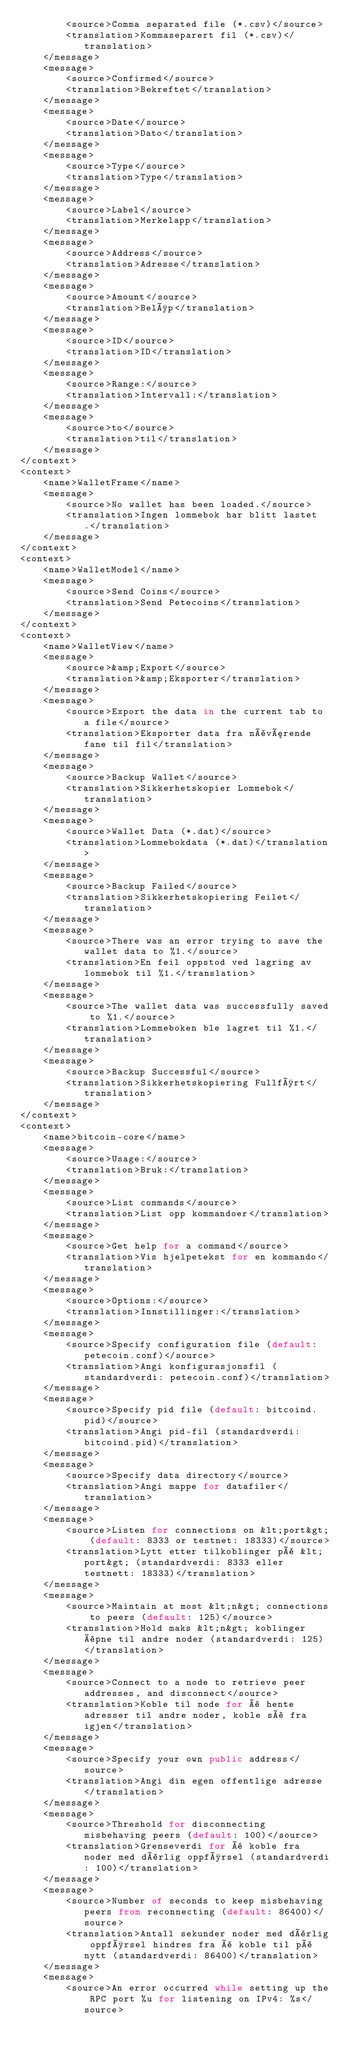<code> <loc_0><loc_0><loc_500><loc_500><_TypeScript_>        <source>Comma separated file (*.csv)</source>
        <translation>Kommaseparert fil (*.csv)</translation>
    </message>
    <message>
        <source>Confirmed</source>
        <translation>Bekreftet</translation>
    </message>
    <message>
        <source>Date</source>
        <translation>Dato</translation>
    </message>
    <message>
        <source>Type</source>
        <translation>Type</translation>
    </message>
    <message>
        <source>Label</source>
        <translation>Merkelapp</translation>
    </message>
    <message>
        <source>Address</source>
        <translation>Adresse</translation>
    </message>
    <message>
        <source>Amount</source>
        <translation>Beløp</translation>
    </message>
    <message>
        <source>ID</source>
        <translation>ID</translation>
    </message>
    <message>
        <source>Range:</source>
        <translation>Intervall:</translation>
    </message>
    <message>
        <source>to</source>
        <translation>til</translation>
    </message>
</context>
<context>
    <name>WalletFrame</name>
    <message>
        <source>No wallet has been loaded.</source>
        <translation>Ingen lommebok har blitt lastet.</translation>
    </message>
</context>
<context>
    <name>WalletModel</name>
    <message>
        <source>Send Coins</source>
        <translation>Send Petecoins</translation>
    </message>
</context>
<context>
    <name>WalletView</name>
    <message>
        <source>&amp;Export</source>
        <translation>&amp;Eksporter</translation>
    </message>
    <message>
        <source>Export the data in the current tab to a file</source>
        <translation>Eksporter data fra nåværende fane til fil</translation>
    </message>
    <message>
        <source>Backup Wallet</source>
        <translation>Sikkerhetskopier Lommebok</translation>
    </message>
    <message>
        <source>Wallet Data (*.dat)</source>
        <translation>Lommebokdata (*.dat)</translation>
    </message>
    <message>
        <source>Backup Failed</source>
        <translation>Sikkerhetskopiering Feilet</translation>
    </message>
    <message>
        <source>There was an error trying to save the wallet data to %1.</source>
        <translation>En feil oppstod ved lagring av lommebok til %1.</translation>
    </message>
    <message>
        <source>The wallet data was successfully saved to %1.</source>
        <translation>Lommeboken ble lagret til %1.</translation>
    </message>
    <message>
        <source>Backup Successful</source>
        <translation>Sikkerhetskopiering Fullført</translation>
    </message>
</context>
<context>
    <name>bitcoin-core</name>
    <message>
        <source>Usage:</source>
        <translation>Bruk:</translation>
    </message>
    <message>
        <source>List commands</source>
        <translation>List opp kommandoer</translation>
    </message>
    <message>
        <source>Get help for a command</source>
        <translation>Vis hjelpetekst for en kommando</translation>
    </message>
    <message>
        <source>Options:</source>
        <translation>Innstillinger:</translation>
    </message>
    <message>
        <source>Specify configuration file (default: petecoin.conf)</source>
        <translation>Angi konfigurasjonsfil (standardverdi: petecoin.conf)</translation>
    </message>
    <message>
        <source>Specify pid file (default: bitcoind.pid)</source>
        <translation>Angi pid-fil (standardverdi: bitcoind.pid)</translation>
    </message>
    <message>
        <source>Specify data directory</source>
        <translation>Angi mappe for datafiler</translation>
    </message>
    <message>
        <source>Listen for connections on &lt;port&gt; (default: 8333 or testnet: 18333)</source>
        <translation>Lytt etter tilkoblinger på &lt;port&gt; (standardverdi: 8333 eller testnett: 18333)</translation>
    </message>
    <message>
        <source>Maintain at most &lt;n&gt; connections to peers (default: 125)</source>
        <translation>Hold maks &lt;n&gt; koblinger åpne til andre noder (standardverdi: 125)</translation>
    </message>
    <message>
        <source>Connect to a node to retrieve peer addresses, and disconnect</source>
        <translation>Koble til node for å hente adresser til andre noder, koble så fra igjen</translation>
    </message>
    <message>
        <source>Specify your own public address</source>
        <translation>Angi din egen offentlige adresse</translation>
    </message>
    <message>
        <source>Threshold for disconnecting misbehaving peers (default: 100)</source>
        <translation>Grenseverdi for å koble fra noder med dårlig oppførsel (standardverdi: 100)</translation>
    </message>
    <message>
        <source>Number of seconds to keep misbehaving peers from reconnecting (default: 86400)</source>
        <translation>Antall sekunder noder med dårlig oppførsel hindres fra å koble til på nytt (standardverdi: 86400)</translation>
    </message>
    <message>
        <source>An error occurred while setting up the RPC port %u for listening on IPv4: %s</source></code> 